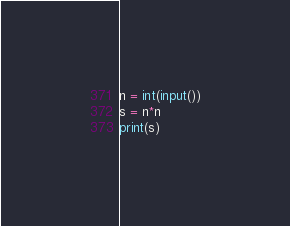<code> <loc_0><loc_0><loc_500><loc_500><_Python_>n = int(input())
s = n*n
print(s)</code> 